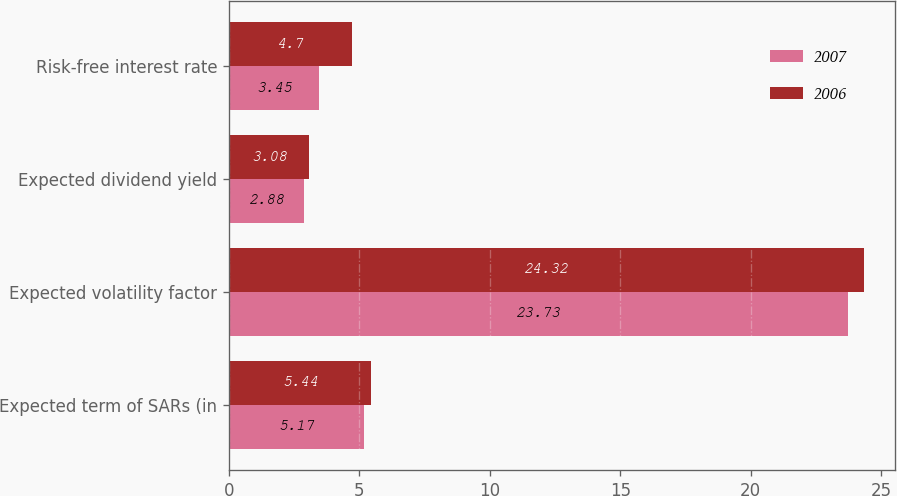Convert chart to OTSL. <chart><loc_0><loc_0><loc_500><loc_500><stacked_bar_chart><ecel><fcel>Expected term of SARs (in<fcel>Expected volatility factor<fcel>Expected dividend yield<fcel>Risk-free interest rate<nl><fcel>2007<fcel>5.17<fcel>23.73<fcel>2.88<fcel>3.45<nl><fcel>2006<fcel>5.44<fcel>24.32<fcel>3.08<fcel>4.7<nl></chart> 